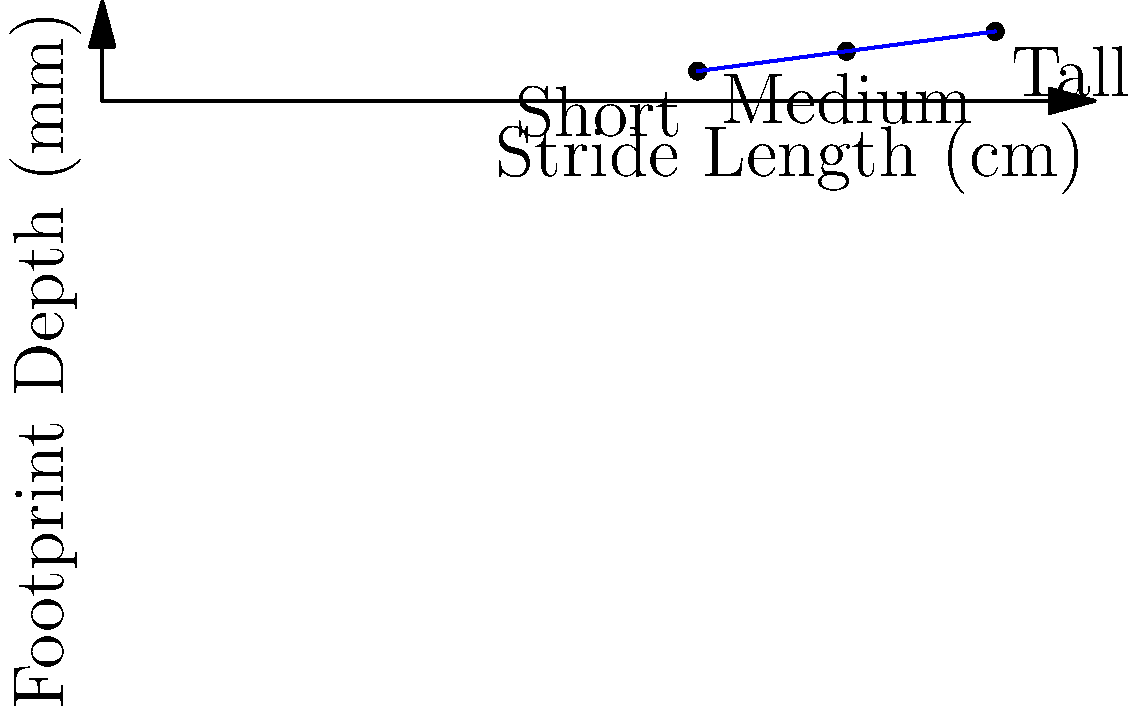Based on the graph showing the relationship between stride length and footprint depth, estimate the height and weight of a perpetrator whose crime scene evidence indicates a stride length of 82 cm and a footprint depth of 6 mm. How would this information aid in narrowing down potential suspects? To estimate the height and weight of the perpetrator:

1. Analyze the graph:
   - Short person: 60 cm stride, 3 mm depth
   - Medium person: 75 cm stride, 5 mm depth
   - Tall person: 90 cm stride, 7 mm depth

2. Interpolate for 82 cm stride and 6 mm depth:
   - The perpetrator's measurements fall between "Medium" and "Tall"

3. Estimate height:
   - Assume "Medium" is about 170 cm and "Tall" is about 190 cm
   - Perpetrator's height ≈ 170 + (82-75)/(90-75) * (190-170) ≈ 180 cm

4. Estimate weight:
   - Assume "Medium" is about 70 kg and "Tall" is about 90 kg
   - Perpetrator's weight ≈ 70 + (82-75)/(90-75) * (90-70) ≈ 80 kg

5. Use in investigation:
   - Narrow suspect pool to individuals around 180 cm tall and 80 kg
   - Combine with other evidence (e.g., witness descriptions, CCTV footage)
   - Use for exclusion or inclusion of suspects based on physical characteristics

This biomechanical analysis provides a scientific basis for suspect profiling, demonstrating the value of forensic science in modern policing techniques.
Answer: Height: ~180 cm, Weight: ~80 kg; aids in narrowing suspect pool based on physical characteristics. 